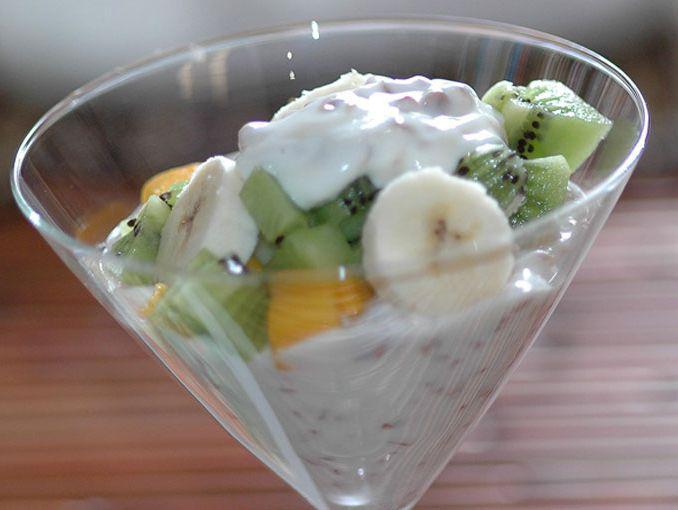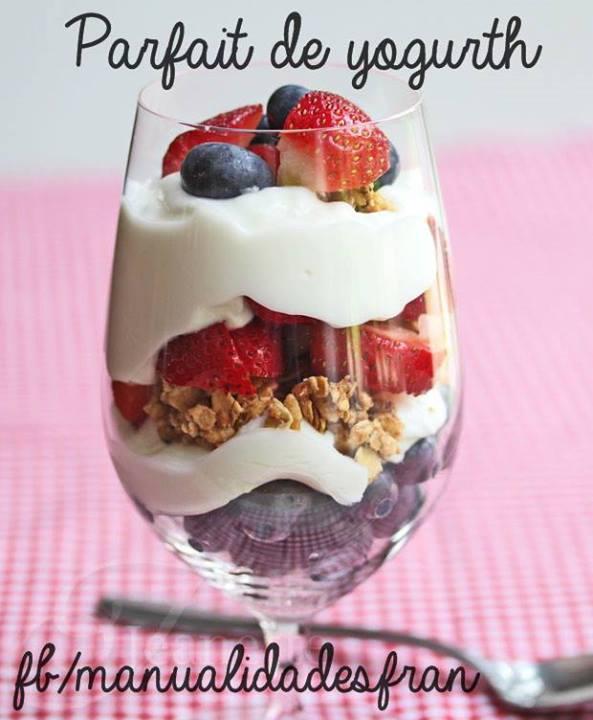The first image is the image on the left, the second image is the image on the right. Evaluate the accuracy of this statement regarding the images: "There is exactly one dessert in an open jar in one of the images". Is it true? Answer yes or no. No. 